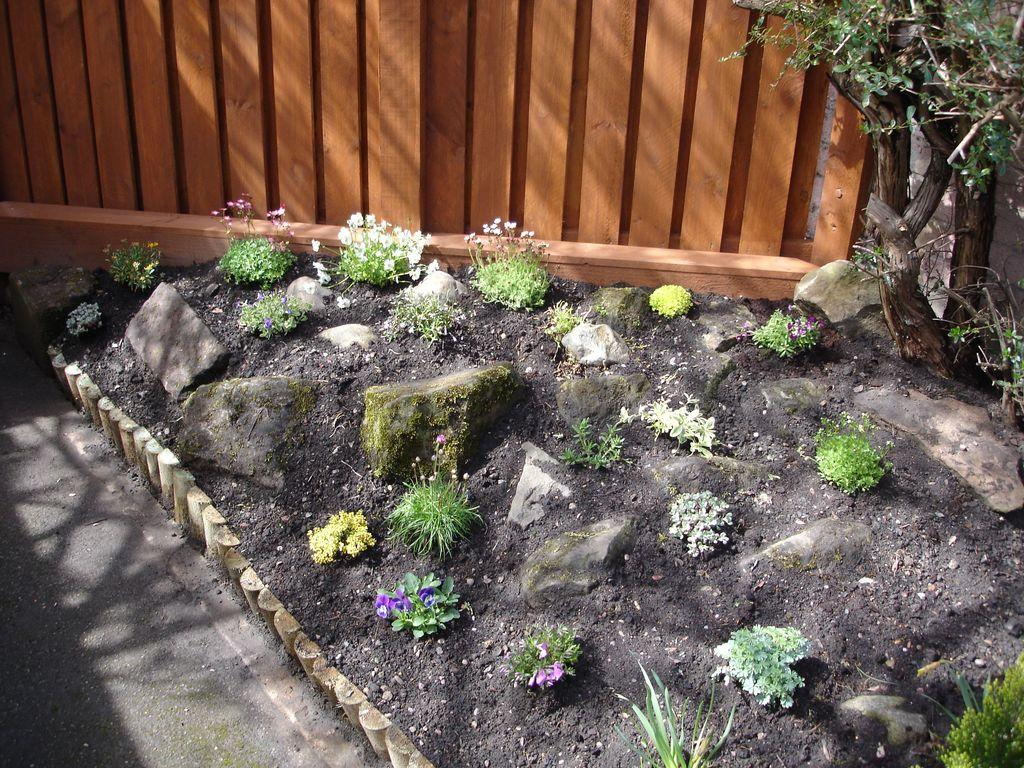What type of plants can be seen in the image? There are plants with flowers in the image. What can be found on the ground in the image? There are stones on the ground in the image. What is visible in the background of the image? There is a tree and a wall in the background of the image. How many hearts can be seen in the image? There are no hearts visible in the image; it features plants with flowers, stones on the ground, and a tree and wall in the background. 